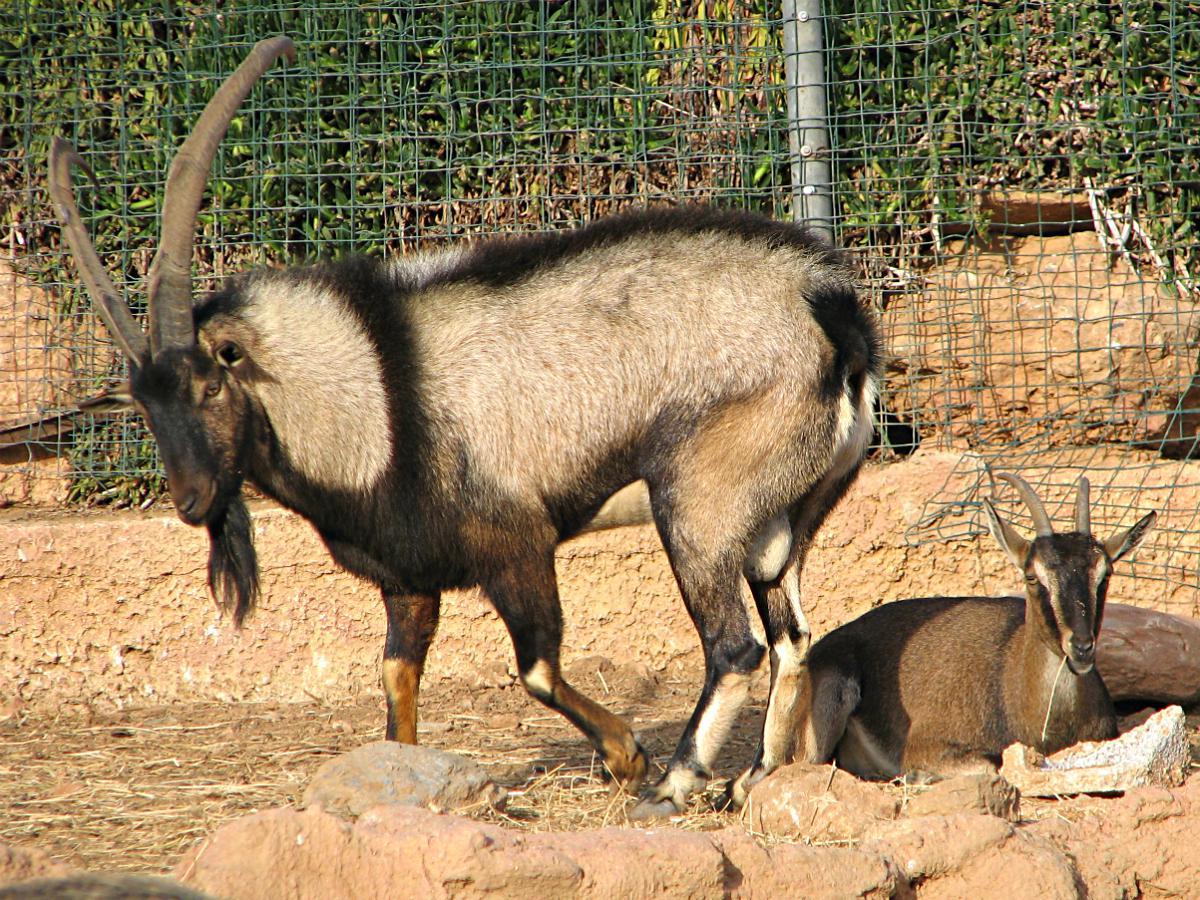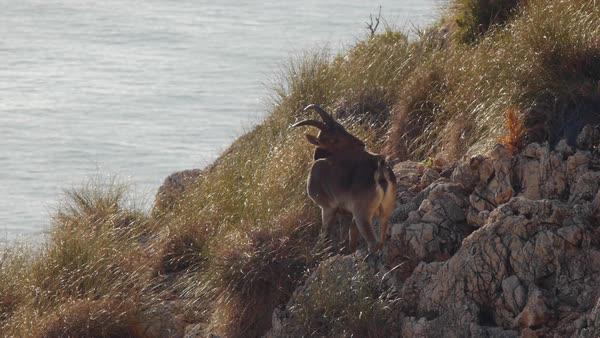The first image is the image on the left, the second image is the image on the right. Considering the images on both sides, is "The animals in the image on the right are on a snowy rocky cliff." valid? Answer yes or no. No. The first image is the image on the left, the second image is the image on the right. Given the left and right images, does the statement "An image shows two hooved animals on a rocky mountainside with patches of white snow." hold true? Answer yes or no. No. 